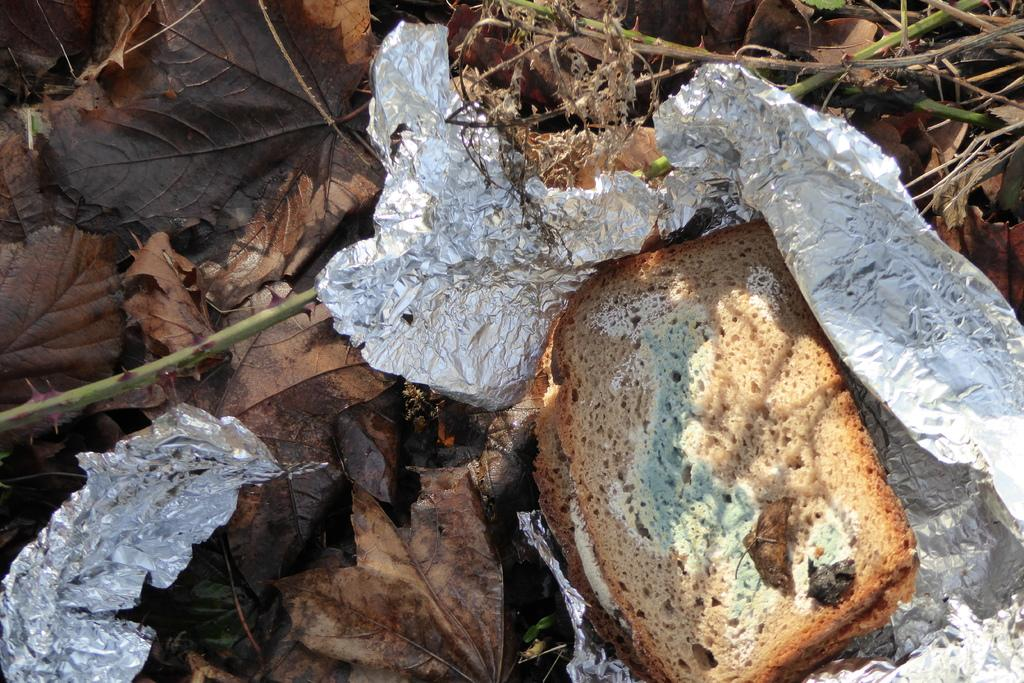What type of food is shown in the image? There are moldy breads in the image. How are the moldy breads placed? The moldy breads are on aluminium foil. What is the surface beneath the aluminium foil? The aluminium foil is on dry leaves. What type of support can be seen holding up the beef in the image? There is no beef present in the image, and therefore no support for it. 